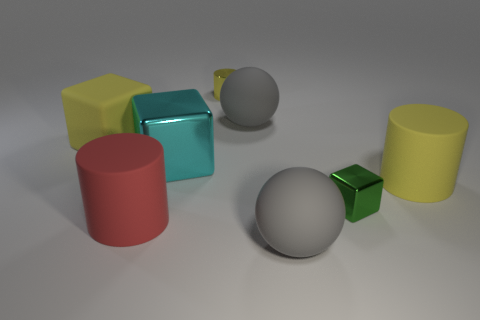Subtract all small cylinders. How many cylinders are left? 2 Add 2 red rubber things. How many objects exist? 10 Subtract all gray objects. Subtract all large red matte cylinders. How many objects are left? 5 Add 6 red rubber objects. How many red rubber objects are left? 7 Add 2 big blue matte cylinders. How many big blue matte cylinders exist? 2 Subtract 0 yellow spheres. How many objects are left? 8 Subtract all cylinders. How many objects are left? 5 